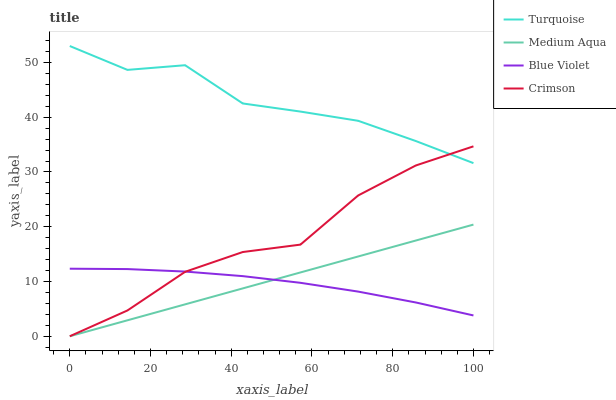Does Medium Aqua have the minimum area under the curve?
Answer yes or no. No. Does Medium Aqua have the maximum area under the curve?
Answer yes or no. No. Is Turquoise the smoothest?
Answer yes or no. No. Is Turquoise the roughest?
Answer yes or no. No. Does Turquoise have the lowest value?
Answer yes or no. No. Does Medium Aqua have the highest value?
Answer yes or no. No. Is Blue Violet less than Turquoise?
Answer yes or no. Yes. Is Turquoise greater than Blue Violet?
Answer yes or no. Yes. Does Blue Violet intersect Turquoise?
Answer yes or no. No. 